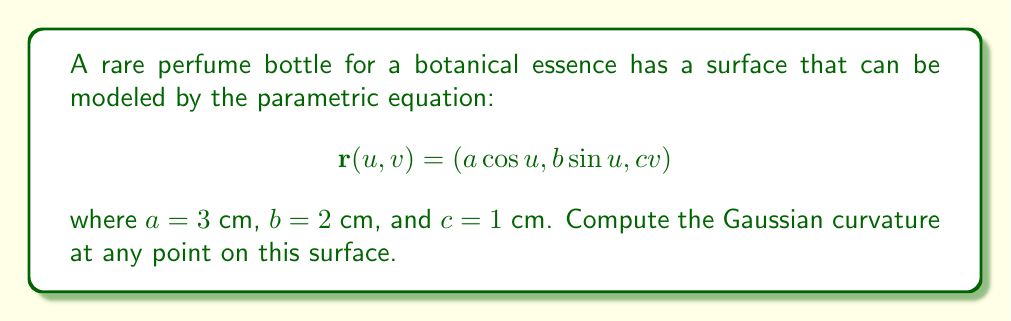Give your solution to this math problem. To find the Gaussian curvature, we'll follow these steps:

1) First, we need to calculate the first fundamental form coefficients:
   $$E = \mathbf{r}_u \cdot \mathbf{r}_u, \quad F = \mathbf{r}_u \cdot \mathbf{r}_v, \quad G = \mathbf{r}_v \cdot \mathbf{r}_v$$

2) Then, we'll calculate the second fundamental form coefficients:
   $$L = \mathbf{n} \cdot \mathbf{r}_{uu}, \quad M = \mathbf{n} \cdot \mathbf{r}_{uv}, \quad N = \mathbf{n} \cdot \mathbf{r}_{vv}$$
   where $\mathbf{n}$ is the unit normal vector.

3) Finally, we'll use the formula for Gaussian curvature:
   $$K = \frac{LN - M^2}{EG - F^2}$$

Step 1: Calculating first fundamental form coefficients
$$\mathbf{r}_u = (-a\sin u, b\cos u, 0)$$
$$\mathbf{r}_v = (0, 0, c)$$

$$E = a^2\sin^2 u + b^2\cos^2 u$$
$$F = 0$$
$$G = c^2$$

Step 2: Calculating second fundamental form coefficients
$$\mathbf{r}_{uu} = (-a\cos u, -b\sin u, 0)$$
$$\mathbf{r}_{uv} = \mathbf{r}_{vu} = (0, 0, 0)$$
$$\mathbf{r}_{vv} = (0, 0, 0)$$

The unit normal vector:
$$\mathbf{n} = \frac{\mathbf{r}_u \times \mathbf{r}_v}{|\mathbf{r}_u \times \mathbf{r}_v|} = \frac{(bc\cos u, ac\sin u, -ab)}{c\sqrt{a^2\sin^2 u + b^2\cos^2 u}}$$

Now we can calculate L, M, and N:
$$L = \frac{-abc}{\sqrt{a^2\sin^2 u + b^2\cos^2 u}}$$
$$M = 0$$
$$N = 0$$

Step 3: Calculating Gaussian curvature
$$K = \frac{LN - M^2}{EG - F^2} = \frac{0}{c^2(a^2\sin^2 u + b^2\cos^2 u) - 0} = 0$$

Substituting the given values $a=3$, $b=2$, and $c=1$ doesn't change this result.
Answer: $K = 0$ 